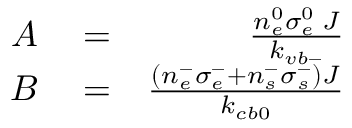<formula> <loc_0><loc_0><loc_500><loc_500>\begin{array} { r l r } { A } & = } & { \frac { n _ { e } ^ { 0 } \sigma _ { e } ^ { 0 } \, J } { k _ { v b - } } } \\ { B } & = } & { \frac { \left ( n _ { e } ^ { - } \sigma _ { e } ^ { - } + n _ { s } ^ { - } \sigma _ { s } ^ { - } \right ) J } { k _ { c b 0 } } } \end{array}</formula> 